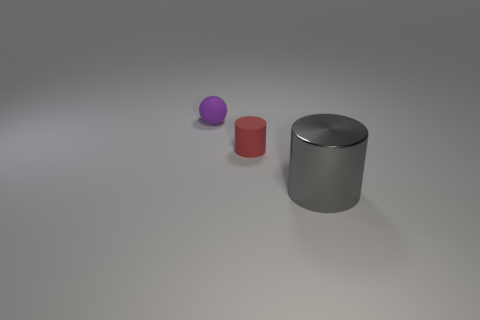Add 1 purple matte things. How many objects exist? 4 Subtract all cylinders. How many objects are left? 1 Add 2 big matte things. How many big matte things exist? 2 Subtract 0 cyan spheres. How many objects are left? 3 Subtract all matte spheres. Subtract all tiny purple matte spheres. How many objects are left? 1 Add 1 tiny rubber spheres. How many tiny rubber spheres are left? 2 